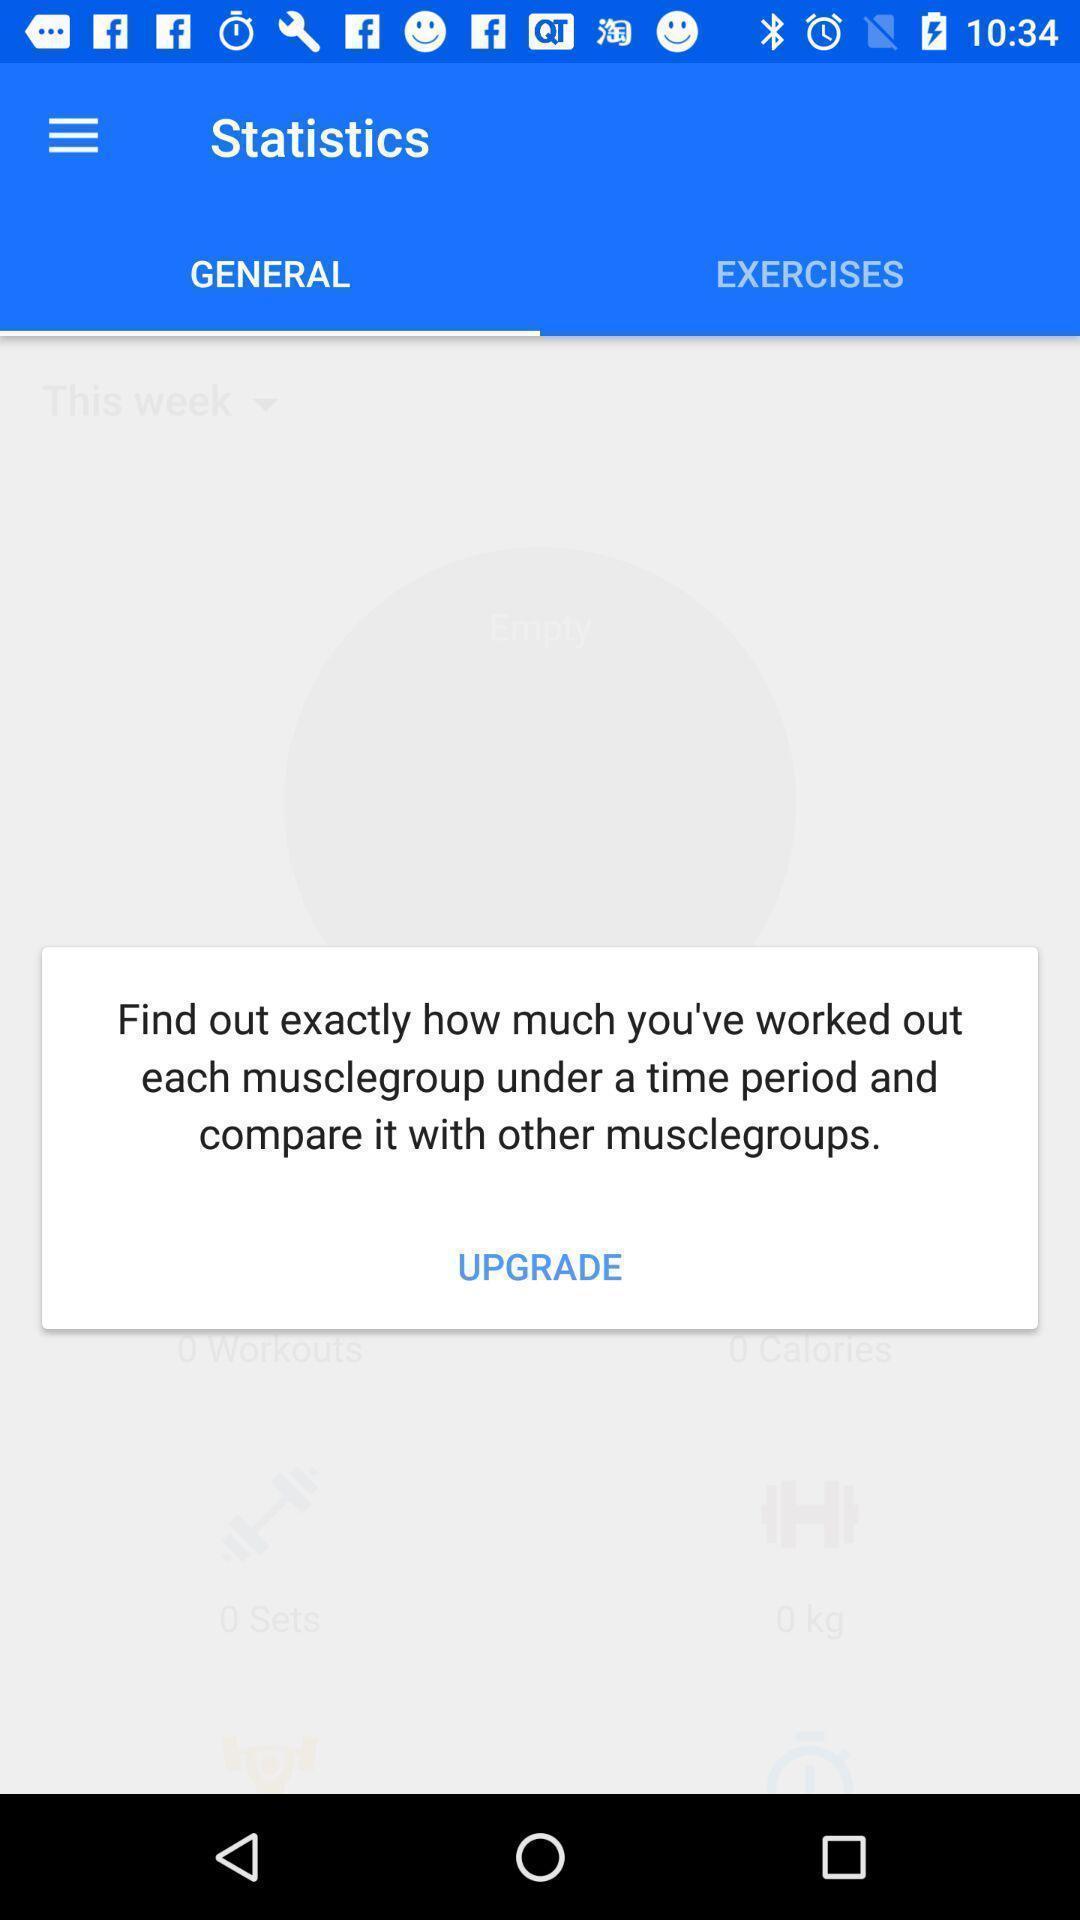What can you discern from this picture? Page showing general statistics on a fitness app. 